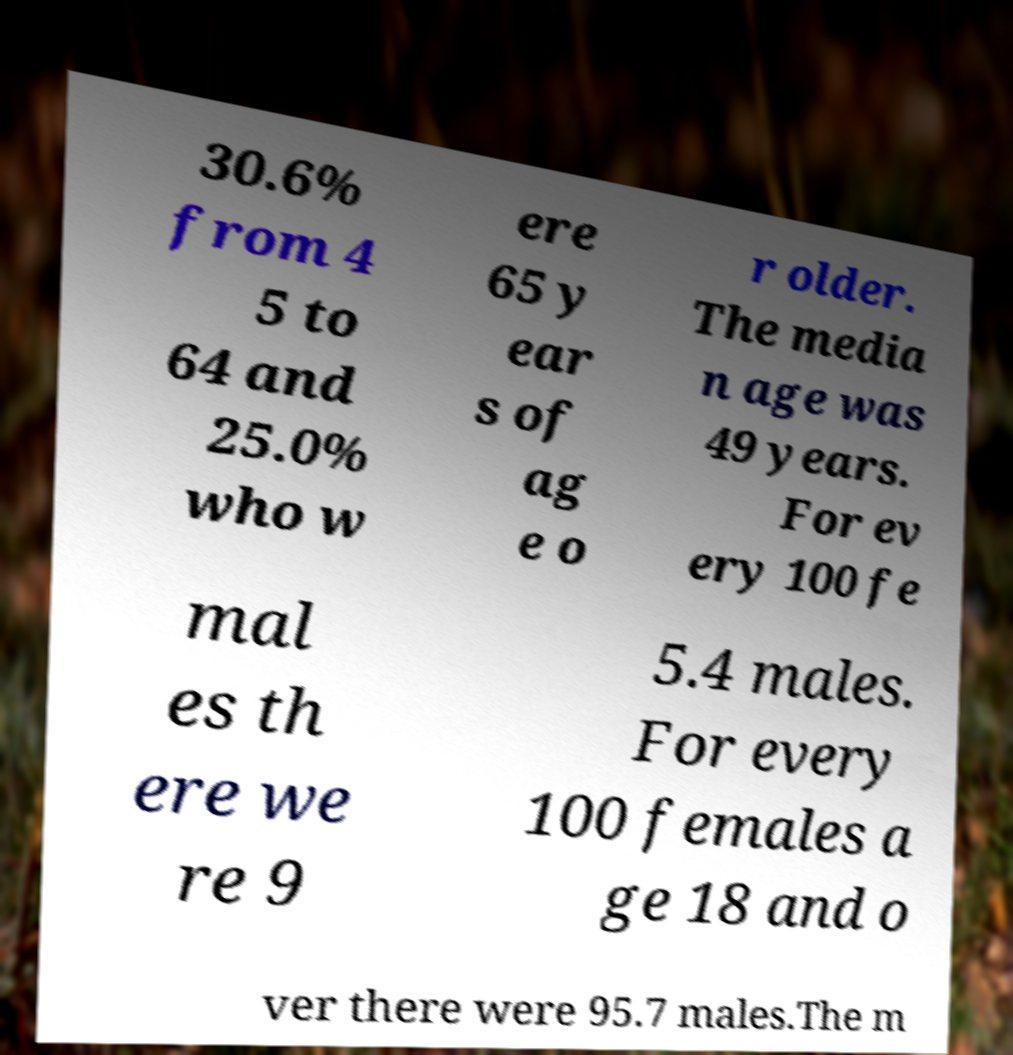For documentation purposes, I need the text within this image transcribed. Could you provide that? 30.6% from 4 5 to 64 and 25.0% who w ere 65 y ear s of ag e o r older. The media n age was 49 years. For ev ery 100 fe mal es th ere we re 9 5.4 males. For every 100 females a ge 18 and o ver there were 95.7 males.The m 